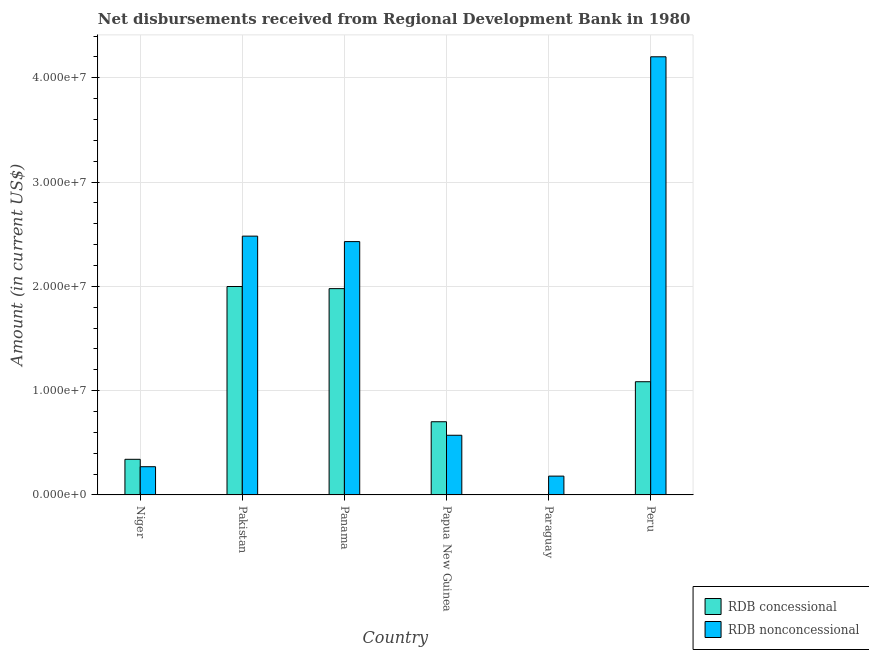Are the number of bars per tick equal to the number of legend labels?
Provide a short and direct response. No. Are the number of bars on each tick of the X-axis equal?
Your answer should be very brief. No. How many bars are there on the 3rd tick from the right?
Keep it short and to the point. 2. What is the label of the 5th group of bars from the left?
Your answer should be compact. Paraguay. In how many cases, is the number of bars for a given country not equal to the number of legend labels?
Your answer should be very brief. 1. What is the net non concessional disbursements from rdb in Paraguay?
Give a very brief answer. 1.80e+06. Across all countries, what is the maximum net concessional disbursements from rdb?
Make the answer very short. 2.00e+07. Across all countries, what is the minimum net non concessional disbursements from rdb?
Your answer should be compact. 1.80e+06. In which country was the net non concessional disbursements from rdb maximum?
Give a very brief answer. Peru. What is the total net concessional disbursements from rdb in the graph?
Offer a terse response. 6.11e+07. What is the difference between the net non concessional disbursements from rdb in Papua New Guinea and that in Paraguay?
Keep it short and to the point. 3.92e+06. What is the difference between the net non concessional disbursements from rdb in Peru and the net concessional disbursements from rdb in Pakistan?
Offer a very short reply. 2.20e+07. What is the average net concessional disbursements from rdb per country?
Your answer should be compact. 1.02e+07. What is the difference between the net non concessional disbursements from rdb and net concessional disbursements from rdb in Pakistan?
Your answer should be compact. 4.83e+06. What is the ratio of the net concessional disbursements from rdb in Niger to that in Peru?
Ensure brevity in your answer.  0.31. What is the difference between the highest and the second highest net non concessional disbursements from rdb?
Offer a very short reply. 1.72e+07. What is the difference between the highest and the lowest net concessional disbursements from rdb?
Make the answer very short. 2.00e+07. In how many countries, is the net non concessional disbursements from rdb greater than the average net non concessional disbursements from rdb taken over all countries?
Keep it short and to the point. 3. Is the sum of the net concessional disbursements from rdb in Papua New Guinea and Peru greater than the maximum net non concessional disbursements from rdb across all countries?
Give a very brief answer. No. How many countries are there in the graph?
Your answer should be compact. 6. What is the difference between two consecutive major ticks on the Y-axis?
Offer a terse response. 1.00e+07. Are the values on the major ticks of Y-axis written in scientific E-notation?
Keep it short and to the point. Yes. Does the graph contain any zero values?
Provide a succinct answer. Yes. Where does the legend appear in the graph?
Give a very brief answer. Bottom right. What is the title of the graph?
Your answer should be compact. Net disbursements received from Regional Development Bank in 1980. What is the label or title of the Y-axis?
Your response must be concise. Amount (in current US$). What is the Amount (in current US$) of RDB concessional in Niger?
Offer a very short reply. 3.42e+06. What is the Amount (in current US$) in RDB nonconcessional in Niger?
Your answer should be compact. 2.71e+06. What is the Amount (in current US$) of RDB concessional in Pakistan?
Your response must be concise. 2.00e+07. What is the Amount (in current US$) in RDB nonconcessional in Pakistan?
Offer a very short reply. 2.48e+07. What is the Amount (in current US$) of RDB concessional in Panama?
Give a very brief answer. 1.98e+07. What is the Amount (in current US$) in RDB nonconcessional in Panama?
Provide a short and direct response. 2.43e+07. What is the Amount (in current US$) in RDB concessional in Papua New Guinea?
Provide a short and direct response. 7.02e+06. What is the Amount (in current US$) of RDB nonconcessional in Papua New Guinea?
Offer a very short reply. 5.72e+06. What is the Amount (in current US$) of RDB concessional in Paraguay?
Make the answer very short. 0. What is the Amount (in current US$) in RDB nonconcessional in Paraguay?
Provide a succinct answer. 1.80e+06. What is the Amount (in current US$) in RDB concessional in Peru?
Give a very brief answer. 1.09e+07. What is the Amount (in current US$) in RDB nonconcessional in Peru?
Make the answer very short. 4.20e+07. Across all countries, what is the maximum Amount (in current US$) of RDB concessional?
Your answer should be very brief. 2.00e+07. Across all countries, what is the maximum Amount (in current US$) of RDB nonconcessional?
Your answer should be very brief. 4.20e+07. Across all countries, what is the minimum Amount (in current US$) in RDB nonconcessional?
Your answer should be very brief. 1.80e+06. What is the total Amount (in current US$) of RDB concessional in the graph?
Offer a very short reply. 6.11e+07. What is the total Amount (in current US$) of RDB nonconcessional in the graph?
Keep it short and to the point. 1.01e+08. What is the difference between the Amount (in current US$) of RDB concessional in Niger and that in Pakistan?
Your answer should be very brief. -1.66e+07. What is the difference between the Amount (in current US$) in RDB nonconcessional in Niger and that in Pakistan?
Your answer should be compact. -2.21e+07. What is the difference between the Amount (in current US$) in RDB concessional in Niger and that in Panama?
Keep it short and to the point. -1.64e+07. What is the difference between the Amount (in current US$) of RDB nonconcessional in Niger and that in Panama?
Your response must be concise. -2.16e+07. What is the difference between the Amount (in current US$) in RDB concessional in Niger and that in Papua New Guinea?
Give a very brief answer. -3.60e+06. What is the difference between the Amount (in current US$) of RDB nonconcessional in Niger and that in Papua New Guinea?
Your response must be concise. -3.02e+06. What is the difference between the Amount (in current US$) of RDB nonconcessional in Niger and that in Paraguay?
Your response must be concise. 9.02e+05. What is the difference between the Amount (in current US$) of RDB concessional in Niger and that in Peru?
Keep it short and to the point. -7.44e+06. What is the difference between the Amount (in current US$) of RDB nonconcessional in Niger and that in Peru?
Your response must be concise. -3.93e+07. What is the difference between the Amount (in current US$) in RDB concessional in Pakistan and that in Panama?
Offer a terse response. 2.04e+05. What is the difference between the Amount (in current US$) of RDB nonconcessional in Pakistan and that in Panama?
Make the answer very short. 5.25e+05. What is the difference between the Amount (in current US$) of RDB concessional in Pakistan and that in Papua New Guinea?
Offer a very short reply. 1.30e+07. What is the difference between the Amount (in current US$) in RDB nonconcessional in Pakistan and that in Papua New Guinea?
Offer a very short reply. 1.91e+07. What is the difference between the Amount (in current US$) of RDB nonconcessional in Pakistan and that in Paraguay?
Offer a terse response. 2.30e+07. What is the difference between the Amount (in current US$) in RDB concessional in Pakistan and that in Peru?
Give a very brief answer. 9.13e+06. What is the difference between the Amount (in current US$) of RDB nonconcessional in Pakistan and that in Peru?
Your response must be concise. -1.72e+07. What is the difference between the Amount (in current US$) of RDB concessional in Panama and that in Papua New Guinea?
Provide a short and direct response. 1.28e+07. What is the difference between the Amount (in current US$) in RDB nonconcessional in Panama and that in Papua New Guinea?
Give a very brief answer. 1.86e+07. What is the difference between the Amount (in current US$) in RDB nonconcessional in Panama and that in Paraguay?
Ensure brevity in your answer.  2.25e+07. What is the difference between the Amount (in current US$) in RDB concessional in Panama and that in Peru?
Offer a very short reply. 8.93e+06. What is the difference between the Amount (in current US$) in RDB nonconcessional in Panama and that in Peru?
Ensure brevity in your answer.  -1.77e+07. What is the difference between the Amount (in current US$) in RDB nonconcessional in Papua New Guinea and that in Paraguay?
Ensure brevity in your answer.  3.92e+06. What is the difference between the Amount (in current US$) in RDB concessional in Papua New Guinea and that in Peru?
Offer a very short reply. -3.84e+06. What is the difference between the Amount (in current US$) in RDB nonconcessional in Papua New Guinea and that in Peru?
Your answer should be very brief. -3.63e+07. What is the difference between the Amount (in current US$) in RDB nonconcessional in Paraguay and that in Peru?
Your response must be concise. -4.02e+07. What is the difference between the Amount (in current US$) of RDB concessional in Niger and the Amount (in current US$) of RDB nonconcessional in Pakistan?
Make the answer very short. -2.14e+07. What is the difference between the Amount (in current US$) of RDB concessional in Niger and the Amount (in current US$) of RDB nonconcessional in Panama?
Make the answer very short. -2.09e+07. What is the difference between the Amount (in current US$) of RDB concessional in Niger and the Amount (in current US$) of RDB nonconcessional in Papua New Guinea?
Offer a very short reply. -2.30e+06. What is the difference between the Amount (in current US$) in RDB concessional in Niger and the Amount (in current US$) in RDB nonconcessional in Paraguay?
Your response must be concise. 1.61e+06. What is the difference between the Amount (in current US$) of RDB concessional in Niger and the Amount (in current US$) of RDB nonconcessional in Peru?
Keep it short and to the point. -3.86e+07. What is the difference between the Amount (in current US$) in RDB concessional in Pakistan and the Amount (in current US$) in RDB nonconcessional in Panama?
Provide a short and direct response. -4.31e+06. What is the difference between the Amount (in current US$) in RDB concessional in Pakistan and the Amount (in current US$) in RDB nonconcessional in Papua New Guinea?
Keep it short and to the point. 1.43e+07. What is the difference between the Amount (in current US$) of RDB concessional in Pakistan and the Amount (in current US$) of RDB nonconcessional in Paraguay?
Give a very brief answer. 1.82e+07. What is the difference between the Amount (in current US$) of RDB concessional in Pakistan and the Amount (in current US$) of RDB nonconcessional in Peru?
Make the answer very short. -2.20e+07. What is the difference between the Amount (in current US$) of RDB concessional in Panama and the Amount (in current US$) of RDB nonconcessional in Papua New Guinea?
Give a very brief answer. 1.41e+07. What is the difference between the Amount (in current US$) in RDB concessional in Panama and the Amount (in current US$) in RDB nonconcessional in Paraguay?
Offer a terse response. 1.80e+07. What is the difference between the Amount (in current US$) of RDB concessional in Panama and the Amount (in current US$) of RDB nonconcessional in Peru?
Your answer should be compact. -2.22e+07. What is the difference between the Amount (in current US$) in RDB concessional in Papua New Guinea and the Amount (in current US$) in RDB nonconcessional in Paraguay?
Offer a very short reply. 5.22e+06. What is the difference between the Amount (in current US$) in RDB concessional in Papua New Guinea and the Amount (in current US$) in RDB nonconcessional in Peru?
Give a very brief answer. -3.50e+07. What is the average Amount (in current US$) in RDB concessional per country?
Give a very brief answer. 1.02e+07. What is the average Amount (in current US$) of RDB nonconcessional per country?
Make the answer very short. 1.69e+07. What is the difference between the Amount (in current US$) in RDB concessional and Amount (in current US$) in RDB nonconcessional in Niger?
Ensure brevity in your answer.  7.11e+05. What is the difference between the Amount (in current US$) of RDB concessional and Amount (in current US$) of RDB nonconcessional in Pakistan?
Your answer should be compact. -4.83e+06. What is the difference between the Amount (in current US$) of RDB concessional and Amount (in current US$) of RDB nonconcessional in Panama?
Ensure brevity in your answer.  -4.51e+06. What is the difference between the Amount (in current US$) in RDB concessional and Amount (in current US$) in RDB nonconcessional in Papua New Guinea?
Offer a very short reply. 1.30e+06. What is the difference between the Amount (in current US$) in RDB concessional and Amount (in current US$) in RDB nonconcessional in Peru?
Ensure brevity in your answer.  -3.12e+07. What is the ratio of the Amount (in current US$) of RDB concessional in Niger to that in Pakistan?
Make the answer very short. 0.17. What is the ratio of the Amount (in current US$) of RDB nonconcessional in Niger to that in Pakistan?
Ensure brevity in your answer.  0.11. What is the ratio of the Amount (in current US$) in RDB concessional in Niger to that in Panama?
Your answer should be very brief. 0.17. What is the ratio of the Amount (in current US$) of RDB nonconcessional in Niger to that in Panama?
Offer a very short reply. 0.11. What is the ratio of the Amount (in current US$) in RDB concessional in Niger to that in Papua New Guinea?
Offer a very short reply. 0.49. What is the ratio of the Amount (in current US$) of RDB nonconcessional in Niger to that in Papua New Guinea?
Offer a terse response. 0.47. What is the ratio of the Amount (in current US$) of RDB nonconcessional in Niger to that in Paraguay?
Offer a very short reply. 1.5. What is the ratio of the Amount (in current US$) in RDB concessional in Niger to that in Peru?
Your answer should be very brief. 0.31. What is the ratio of the Amount (in current US$) of RDB nonconcessional in Niger to that in Peru?
Provide a succinct answer. 0.06. What is the ratio of the Amount (in current US$) of RDB concessional in Pakistan to that in Panama?
Offer a very short reply. 1.01. What is the ratio of the Amount (in current US$) in RDB nonconcessional in Pakistan to that in Panama?
Your response must be concise. 1.02. What is the ratio of the Amount (in current US$) of RDB concessional in Pakistan to that in Papua New Guinea?
Provide a short and direct response. 2.85. What is the ratio of the Amount (in current US$) of RDB nonconcessional in Pakistan to that in Papua New Guinea?
Make the answer very short. 4.34. What is the ratio of the Amount (in current US$) in RDB nonconcessional in Pakistan to that in Paraguay?
Provide a succinct answer. 13.76. What is the ratio of the Amount (in current US$) of RDB concessional in Pakistan to that in Peru?
Your answer should be compact. 1.84. What is the ratio of the Amount (in current US$) of RDB nonconcessional in Pakistan to that in Peru?
Provide a succinct answer. 0.59. What is the ratio of the Amount (in current US$) in RDB concessional in Panama to that in Papua New Guinea?
Ensure brevity in your answer.  2.82. What is the ratio of the Amount (in current US$) in RDB nonconcessional in Panama to that in Papua New Guinea?
Offer a terse response. 4.25. What is the ratio of the Amount (in current US$) in RDB nonconcessional in Panama to that in Paraguay?
Give a very brief answer. 13.47. What is the ratio of the Amount (in current US$) in RDB concessional in Panama to that in Peru?
Provide a succinct answer. 1.82. What is the ratio of the Amount (in current US$) in RDB nonconcessional in Panama to that in Peru?
Provide a succinct answer. 0.58. What is the ratio of the Amount (in current US$) of RDB nonconcessional in Papua New Guinea to that in Paraguay?
Your answer should be very brief. 3.17. What is the ratio of the Amount (in current US$) of RDB concessional in Papua New Guinea to that in Peru?
Provide a succinct answer. 0.65. What is the ratio of the Amount (in current US$) in RDB nonconcessional in Papua New Guinea to that in Peru?
Give a very brief answer. 0.14. What is the ratio of the Amount (in current US$) of RDB nonconcessional in Paraguay to that in Peru?
Provide a succinct answer. 0.04. What is the difference between the highest and the second highest Amount (in current US$) of RDB concessional?
Keep it short and to the point. 2.04e+05. What is the difference between the highest and the second highest Amount (in current US$) in RDB nonconcessional?
Your answer should be compact. 1.72e+07. What is the difference between the highest and the lowest Amount (in current US$) in RDB concessional?
Provide a succinct answer. 2.00e+07. What is the difference between the highest and the lowest Amount (in current US$) of RDB nonconcessional?
Make the answer very short. 4.02e+07. 